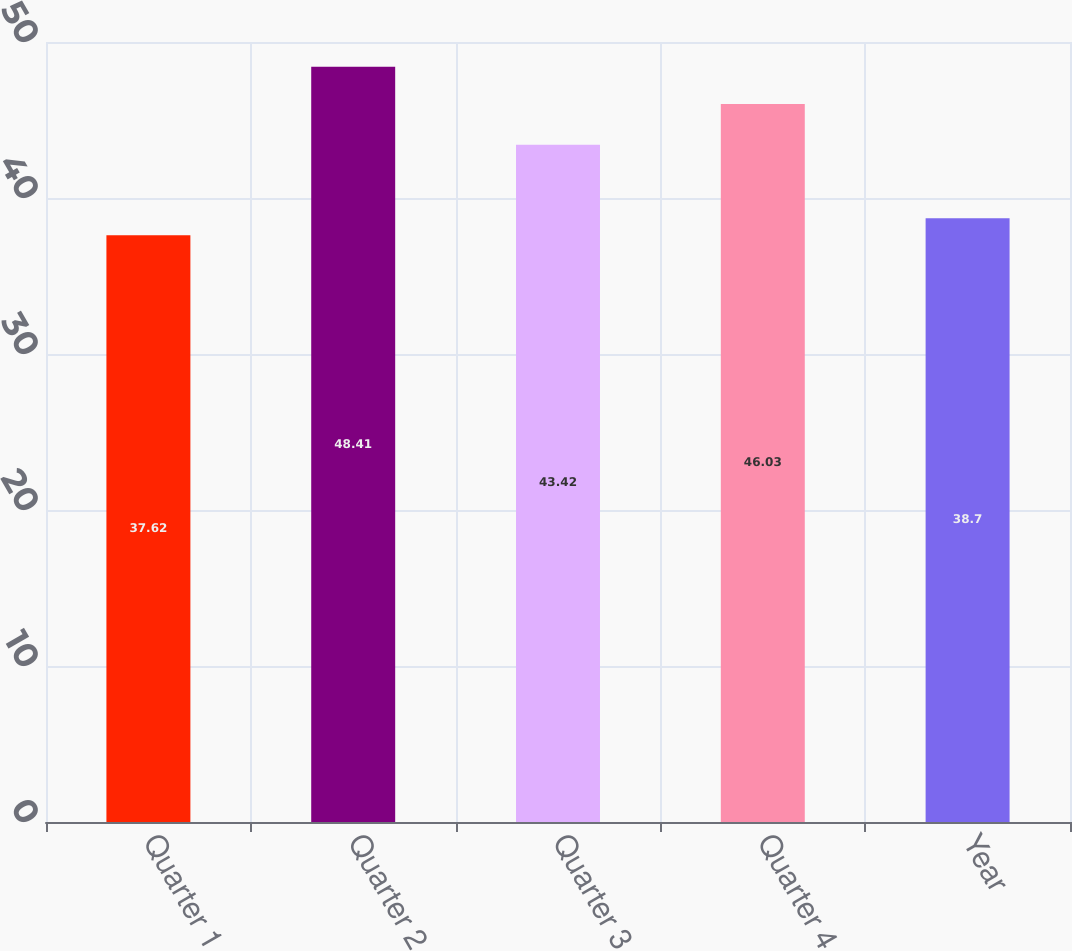Convert chart to OTSL. <chart><loc_0><loc_0><loc_500><loc_500><bar_chart><fcel>Quarter 1<fcel>Quarter 2<fcel>Quarter 3<fcel>Quarter 4<fcel>Year<nl><fcel>37.62<fcel>48.41<fcel>43.42<fcel>46.03<fcel>38.7<nl></chart> 